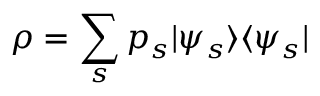Convert formula to latex. <formula><loc_0><loc_0><loc_500><loc_500>\rho = \sum _ { s } p _ { s } | \psi _ { s } \rangle \langle \psi _ { s } |</formula> 